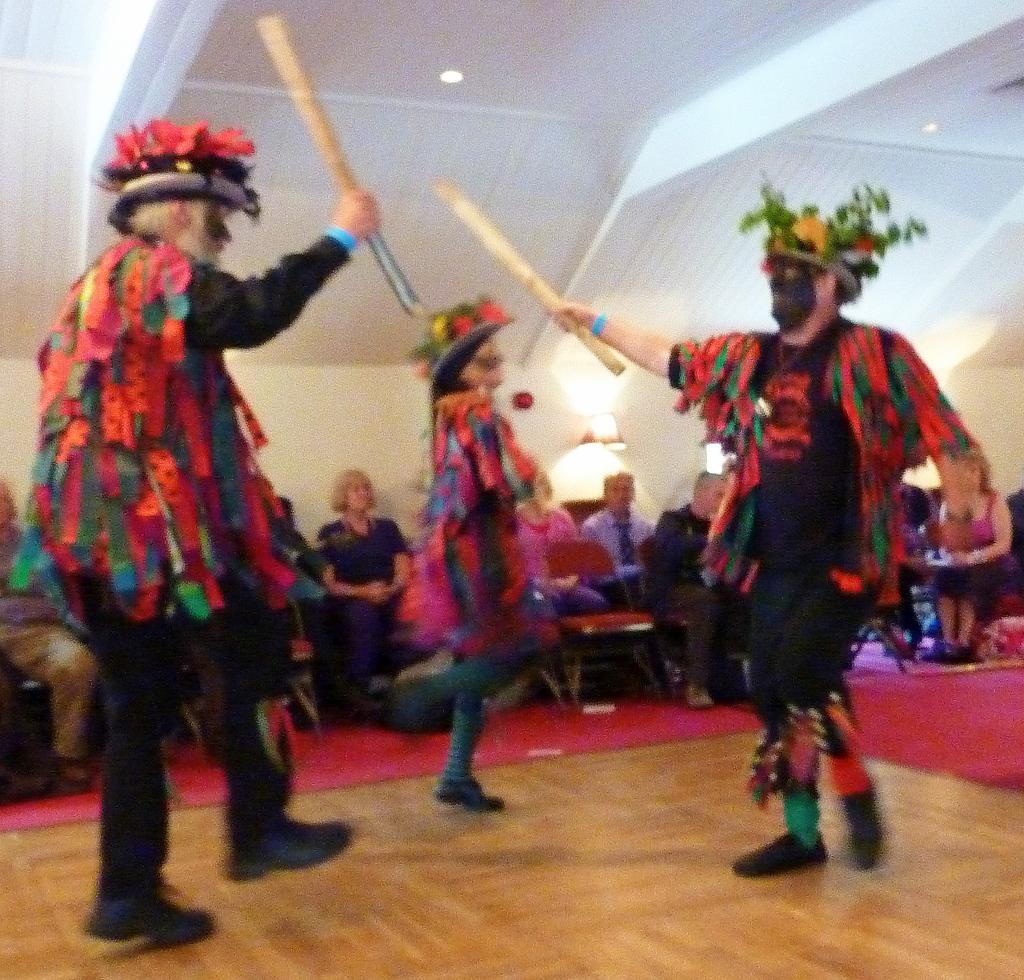How many people are performing in the image? There are three people performing in the image. What type of performance are they engaged in? The three people are performing a cultural dance. What are the dancers holding in their hands? The dancers are holding sticks in their hands. Can you describe the audience in the image? The spectators are seated on chairs in the image. What type of leather is being used to make the celery sticks in the image? There is no leather or celery present in the image; the dancers are holding sticks made of a different material. 